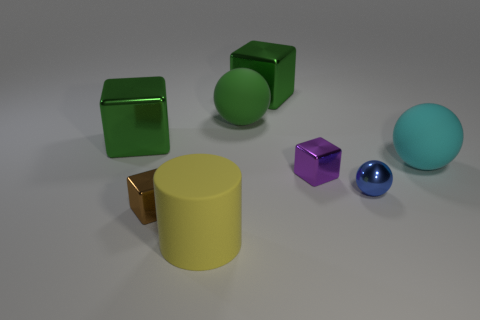How does the lighting in this scene affect the appearance of the objects? The lighting in this scene is soft and diffused, coming from above. It creates gentle shadows on the side of the objects farther from the light source, adding depth and dimensionality to the scene. The reflective spheres catch the light on one side, highlighting their glossy texture, while the matte surfaces of the cubes and the cylinder show more subdued reflections. 